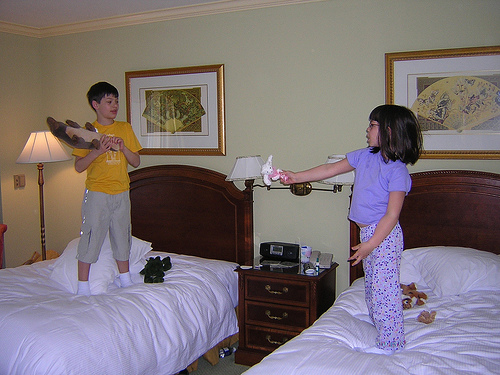<image>
Is there a girl on the bed? Yes. Looking at the image, I can see the girl is positioned on top of the bed, with the bed providing support. Is the girl in front of the boy? Yes. The girl is positioned in front of the boy, appearing closer to the camera viewpoint. 